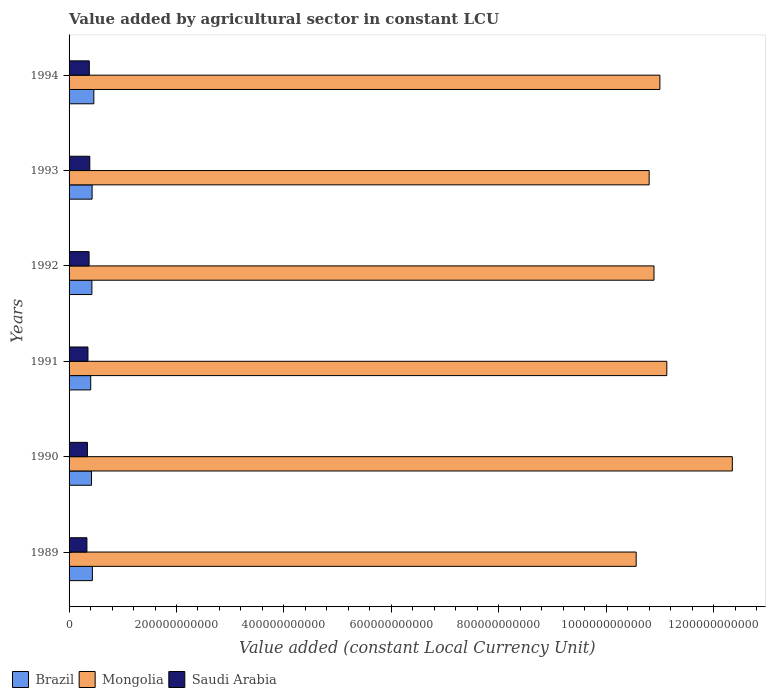How many different coloured bars are there?
Your answer should be compact. 3. Are the number of bars on each tick of the Y-axis equal?
Give a very brief answer. Yes. What is the label of the 3rd group of bars from the top?
Your answer should be very brief. 1992. In how many cases, is the number of bars for a given year not equal to the number of legend labels?
Provide a short and direct response. 0. What is the value added by agricultural sector in Brazil in 1989?
Make the answer very short. 4.34e+1. Across all years, what is the maximum value added by agricultural sector in Mongolia?
Make the answer very short. 1.23e+12. Across all years, what is the minimum value added by agricultural sector in Brazil?
Provide a succinct answer. 4.03e+1. In which year was the value added by agricultural sector in Mongolia maximum?
Make the answer very short. 1990. In which year was the value added by agricultural sector in Mongolia minimum?
Your answer should be compact. 1989. What is the total value added by agricultural sector in Brazil in the graph?
Provide a succinct answer. 2.57e+11. What is the difference between the value added by agricultural sector in Mongolia in 1993 and that in 1994?
Provide a short and direct response. -2.00e+1. What is the difference between the value added by agricultural sector in Mongolia in 1990 and the value added by agricultural sector in Brazil in 1989?
Keep it short and to the point. 1.19e+12. What is the average value added by agricultural sector in Brazil per year?
Offer a terse response. 4.28e+1. In the year 1992, what is the difference between the value added by agricultural sector in Mongolia and value added by agricultural sector in Saudi Arabia?
Give a very brief answer. 1.05e+12. In how many years, is the value added by agricultural sector in Saudi Arabia greater than 1200000000000 LCU?
Your answer should be very brief. 0. What is the ratio of the value added by agricultural sector in Mongolia in 1991 to that in 1992?
Offer a very short reply. 1.02. Is the difference between the value added by agricultural sector in Mongolia in 1992 and 1993 greater than the difference between the value added by agricultural sector in Saudi Arabia in 1992 and 1993?
Your answer should be compact. Yes. What is the difference between the highest and the second highest value added by agricultural sector in Saudi Arabia?
Offer a very short reply. 8.85e+08. What is the difference between the highest and the lowest value added by agricultural sector in Brazil?
Your answer should be compact. 5.80e+09. What does the 1st bar from the top in 1989 represents?
Provide a short and direct response. Saudi Arabia. Is it the case that in every year, the sum of the value added by agricultural sector in Mongolia and value added by agricultural sector in Saudi Arabia is greater than the value added by agricultural sector in Brazil?
Make the answer very short. Yes. How many bars are there?
Make the answer very short. 18. Are all the bars in the graph horizontal?
Offer a terse response. Yes. How many years are there in the graph?
Keep it short and to the point. 6. What is the difference between two consecutive major ticks on the X-axis?
Provide a short and direct response. 2.00e+11. Does the graph contain any zero values?
Your answer should be compact. No. Does the graph contain grids?
Provide a short and direct response. No. What is the title of the graph?
Provide a short and direct response. Value added by agricultural sector in constant LCU. What is the label or title of the X-axis?
Provide a succinct answer. Value added (constant Local Currency Unit). What is the label or title of the Y-axis?
Your response must be concise. Years. What is the Value added (constant Local Currency Unit) in Brazil in 1989?
Offer a very short reply. 4.34e+1. What is the Value added (constant Local Currency Unit) in Mongolia in 1989?
Keep it short and to the point. 1.06e+12. What is the Value added (constant Local Currency Unit) in Saudi Arabia in 1989?
Make the answer very short. 3.32e+1. What is the Value added (constant Local Currency Unit) in Brazil in 1990?
Provide a succinct answer. 4.18e+1. What is the Value added (constant Local Currency Unit) in Mongolia in 1990?
Provide a succinct answer. 1.23e+12. What is the Value added (constant Local Currency Unit) of Saudi Arabia in 1990?
Provide a short and direct response. 3.42e+1. What is the Value added (constant Local Currency Unit) of Brazil in 1991?
Offer a very short reply. 4.03e+1. What is the Value added (constant Local Currency Unit) in Mongolia in 1991?
Your answer should be very brief. 1.11e+12. What is the Value added (constant Local Currency Unit) of Saudi Arabia in 1991?
Your answer should be compact. 3.51e+1. What is the Value added (constant Local Currency Unit) of Brazil in 1992?
Provide a short and direct response. 4.25e+1. What is the Value added (constant Local Currency Unit) of Mongolia in 1992?
Provide a short and direct response. 1.09e+12. What is the Value added (constant Local Currency Unit) in Saudi Arabia in 1992?
Provide a short and direct response. 3.73e+1. What is the Value added (constant Local Currency Unit) of Brazil in 1993?
Your answer should be very brief. 4.29e+1. What is the Value added (constant Local Currency Unit) of Mongolia in 1993?
Your answer should be compact. 1.08e+12. What is the Value added (constant Local Currency Unit) in Saudi Arabia in 1993?
Your answer should be compact. 3.86e+1. What is the Value added (constant Local Currency Unit) in Brazil in 1994?
Ensure brevity in your answer.  4.61e+1. What is the Value added (constant Local Currency Unit) of Mongolia in 1994?
Make the answer very short. 1.10e+12. What is the Value added (constant Local Currency Unit) of Saudi Arabia in 1994?
Keep it short and to the point. 3.77e+1. Across all years, what is the maximum Value added (constant Local Currency Unit) of Brazil?
Keep it short and to the point. 4.61e+1. Across all years, what is the maximum Value added (constant Local Currency Unit) in Mongolia?
Your answer should be very brief. 1.23e+12. Across all years, what is the maximum Value added (constant Local Currency Unit) in Saudi Arabia?
Your response must be concise. 3.86e+1. Across all years, what is the minimum Value added (constant Local Currency Unit) of Brazil?
Make the answer very short. 4.03e+1. Across all years, what is the minimum Value added (constant Local Currency Unit) of Mongolia?
Offer a very short reply. 1.06e+12. Across all years, what is the minimum Value added (constant Local Currency Unit) of Saudi Arabia?
Your answer should be compact. 3.32e+1. What is the total Value added (constant Local Currency Unit) in Brazil in the graph?
Keep it short and to the point. 2.57e+11. What is the total Value added (constant Local Currency Unit) in Mongolia in the graph?
Your response must be concise. 6.67e+12. What is the total Value added (constant Local Currency Unit) in Saudi Arabia in the graph?
Your response must be concise. 2.16e+11. What is the difference between the Value added (constant Local Currency Unit) in Brazil in 1989 and that in 1990?
Make the answer very short. 1.61e+09. What is the difference between the Value added (constant Local Currency Unit) of Mongolia in 1989 and that in 1990?
Offer a very short reply. -1.79e+11. What is the difference between the Value added (constant Local Currency Unit) of Saudi Arabia in 1989 and that in 1990?
Make the answer very short. -9.31e+08. What is the difference between the Value added (constant Local Currency Unit) in Brazil in 1989 and that in 1991?
Your response must be concise. 3.11e+09. What is the difference between the Value added (constant Local Currency Unit) of Mongolia in 1989 and that in 1991?
Offer a very short reply. -5.70e+1. What is the difference between the Value added (constant Local Currency Unit) of Saudi Arabia in 1989 and that in 1991?
Provide a succinct answer. -1.92e+09. What is the difference between the Value added (constant Local Currency Unit) of Brazil in 1989 and that in 1992?
Ensure brevity in your answer.  9.21e+08. What is the difference between the Value added (constant Local Currency Unit) of Mongolia in 1989 and that in 1992?
Keep it short and to the point. -3.32e+1. What is the difference between the Value added (constant Local Currency Unit) in Saudi Arabia in 1989 and that in 1992?
Provide a succinct answer. -4.03e+09. What is the difference between the Value added (constant Local Currency Unit) of Brazil in 1989 and that in 1993?
Give a very brief answer. 5.02e+08. What is the difference between the Value added (constant Local Currency Unit) of Mongolia in 1989 and that in 1993?
Make the answer very short. -2.41e+1. What is the difference between the Value added (constant Local Currency Unit) in Saudi Arabia in 1989 and that in 1993?
Your answer should be compact. -5.34e+09. What is the difference between the Value added (constant Local Currency Unit) of Brazil in 1989 and that in 1994?
Provide a succinct answer. -2.69e+09. What is the difference between the Value added (constant Local Currency Unit) of Mongolia in 1989 and that in 1994?
Your answer should be very brief. -4.42e+1. What is the difference between the Value added (constant Local Currency Unit) of Saudi Arabia in 1989 and that in 1994?
Make the answer very short. -4.45e+09. What is the difference between the Value added (constant Local Currency Unit) in Brazil in 1990 and that in 1991?
Your answer should be compact. 1.51e+09. What is the difference between the Value added (constant Local Currency Unit) in Mongolia in 1990 and that in 1991?
Keep it short and to the point. 1.22e+11. What is the difference between the Value added (constant Local Currency Unit) in Saudi Arabia in 1990 and that in 1991?
Keep it short and to the point. -9.86e+08. What is the difference between the Value added (constant Local Currency Unit) of Brazil in 1990 and that in 1992?
Your answer should be very brief. -6.85e+08. What is the difference between the Value added (constant Local Currency Unit) of Mongolia in 1990 and that in 1992?
Your answer should be compact. 1.46e+11. What is the difference between the Value added (constant Local Currency Unit) of Saudi Arabia in 1990 and that in 1992?
Your answer should be very brief. -3.10e+09. What is the difference between the Value added (constant Local Currency Unit) of Brazil in 1990 and that in 1993?
Ensure brevity in your answer.  -1.10e+09. What is the difference between the Value added (constant Local Currency Unit) of Mongolia in 1990 and that in 1993?
Give a very brief answer. 1.55e+11. What is the difference between the Value added (constant Local Currency Unit) in Saudi Arabia in 1990 and that in 1993?
Keep it short and to the point. -4.41e+09. What is the difference between the Value added (constant Local Currency Unit) of Brazil in 1990 and that in 1994?
Provide a short and direct response. -4.30e+09. What is the difference between the Value added (constant Local Currency Unit) in Mongolia in 1990 and that in 1994?
Your response must be concise. 1.35e+11. What is the difference between the Value added (constant Local Currency Unit) of Saudi Arabia in 1990 and that in 1994?
Provide a short and direct response. -3.52e+09. What is the difference between the Value added (constant Local Currency Unit) of Brazil in 1991 and that in 1992?
Make the answer very short. -2.19e+09. What is the difference between the Value added (constant Local Currency Unit) in Mongolia in 1991 and that in 1992?
Keep it short and to the point. 2.38e+1. What is the difference between the Value added (constant Local Currency Unit) in Saudi Arabia in 1991 and that in 1992?
Your response must be concise. -2.12e+09. What is the difference between the Value added (constant Local Currency Unit) of Brazil in 1991 and that in 1993?
Provide a succinct answer. -2.61e+09. What is the difference between the Value added (constant Local Currency Unit) in Mongolia in 1991 and that in 1993?
Your answer should be compact. 3.29e+1. What is the difference between the Value added (constant Local Currency Unit) of Saudi Arabia in 1991 and that in 1993?
Provide a short and direct response. -3.42e+09. What is the difference between the Value added (constant Local Currency Unit) of Brazil in 1991 and that in 1994?
Ensure brevity in your answer.  -5.80e+09. What is the difference between the Value added (constant Local Currency Unit) in Mongolia in 1991 and that in 1994?
Your answer should be very brief. 1.29e+1. What is the difference between the Value added (constant Local Currency Unit) in Saudi Arabia in 1991 and that in 1994?
Ensure brevity in your answer.  -2.54e+09. What is the difference between the Value added (constant Local Currency Unit) in Brazil in 1992 and that in 1993?
Provide a succinct answer. -4.19e+08. What is the difference between the Value added (constant Local Currency Unit) of Mongolia in 1992 and that in 1993?
Your answer should be compact. 9.04e+09. What is the difference between the Value added (constant Local Currency Unit) of Saudi Arabia in 1992 and that in 1993?
Give a very brief answer. -1.31e+09. What is the difference between the Value added (constant Local Currency Unit) of Brazil in 1992 and that in 1994?
Keep it short and to the point. -3.61e+09. What is the difference between the Value added (constant Local Currency Unit) in Mongolia in 1992 and that in 1994?
Offer a terse response. -1.10e+1. What is the difference between the Value added (constant Local Currency Unit) of Saudi Arabia in 1992 and that in 1994?
Provide a succinct answer. -4.23e+08. What is the difference between the Value added (constant Local Currency Unit) in Brazil in 1993 and that in 1994?
Make the answer very short. -3.19e+09. What is the difference between the Value added (constant Local Currency Unit) of Mongolia in 1993 and that in 1994?
Make the answer very short. -2.00e+1. What is the difference between the Value added (constant Local Currency Unit) in Saudi Arabia in 1993 and that in 1994?
Provide a short and direct response. 8.85e+08. What is the difference between the Value added (constant Local Currency Unit) of Brazil in 1989 and the Value added (constant Local Currency Unit) of Mongolia in 1990?
Offer a terse response. -1.19e+12. What is the difference between the Value added (constant Local Currency Unit) in Brazil in 1989 and the Value added (constant Local Currency Unit) in Saudi Arabia in 1990?
Ensure brevity in your answer.  9.24e+09. What is the difference between the Value added (constant Local Currency Unit) of Mongolia in 1989 and the Value added (constant Local Currency Unit) of Saudi Arabia in 1990?
Provide a succinct answer. 1.02e+12. What is the difference between the Value added (constant Local Currency Unit) of Brazil in 1989 and the Value added (constant Local Currency Unit) of Mongolia in 1991?
Your response must be concise. -1.07e+12. What is the difference between the Value added (constant Local Currency Unit) of Brazil in 1989 and the Value added (constant Local Currency Unit) of Saudi Arabia in 1991?
Make the answer very short. 8.25e+09. What is the difference between the Value added (constant Local Currency Unit) of Mongolia in 1989 and the Value added (constant Local Currency Unit) of Saudi Arabia in 1991?
Offer a terse response. 1.02e+12. What is the difference between the Value added (constant Local Currency Unit) of Brazil in 1989 and the Value added (constant Local Currency Unit) of Mongolia in 1992?
Provide a succinct answer. -1.05e+12. What is the difference between the Value added (constant Local Currency Unit) in Brazil in 1989 and the Value added (constant Local Currency Unit) in Saudi Arabia in 1992?
Give a very brief answer. 6.14e+09. What is the difference between the Value added (constant Local Currency Unit) of Mongolia in 1989 and the Value added (constant Local Currency Unit) of Saudi Arabia in 1992?
Offer a very short reply. 1.02e+12. What is the difference between the Value added (constant Local Currency Unit) of Brazil in 1989 and the Value added (constant Local Currency Unit) of Mongolia in 1993?
Ensure brevity in your answer.  -1.04e+12. What is the difference between the Value added (constant Local Currency Unit) in Brazil in 1989 and the Value added (constant Local Currency Unit) in Saudi Arabia in 1993?
Your answer should be very brief. 4.83e+09. What is the difference between the Value added (constant Local Currency Unit) of Mongolia in 1989 and the Value added (constant Local Currency Unit) of Saudi Arabia in 1993?
Keep it short and to the point. 1.02e+12. What is the difference between the Value added (constant Local Currency Unit) in Brazil in 1989 and the Value added (constant Local Currency Unit) in Mongolia in 1994?
Provide a short and direct response. -1.06e+12. What is the difference between the Value added (constant Local Currency Unit) of Brazil in 1989 and the Value added (constant Local Currency Unit) of Saudi Arabia in 1994?
Offer a very short reply. 5.72e+09. What is the difference between the Value added (constant Local Currency Unit) of Mongolia in 1989 and the Value added (constant Local Currency Unit) of Saudi Arabia in 1994?
Keep it short and to the point. 1.02e+12. What is the difference between the Value added (constant Local Currency Unit) of Brazil in 1990 and the Value added (constant Local Currency Unit) of Mongolia in 1991?
Offer a terse response. -1.07e+12. What is the difference between the Value added (constant Local Currency Unit) in Brazil in 1990 and the Value added (constant Local Currency Unit) in Saudi Arabia in 1991?
Offer a terse response. 6.65e+09. What is the difference between the Value added (constant Local Currency Unit) in Mongolia in 1990 and the Value added (constant Local Currency Unit) in Saudi Arabia in 1991?
Provide a succinct answer. 1.20e+12. What is the difference between the Value added (constant Local Currency Unit) of Brazil in 1990 and the Value added (constant Local Currency Unit) of Mongolia in 1992?
Offer a very short reply. -1.05e+12. What is the difference between the Value added (constant Local Currency Unit) in Brazil in 1990 and the Value added (constant Local Currency Unit) in Saudi Arabia in 1992?
Your answer should be very brief. 4.53e+09. What is the difference between the Value added (constant Local Currency Unit) of Mongolia in 1990 and the Value added (constant Local Currency Unit) of Saudi Arabia in 1992?
Your answer should be compact. 1.20e+12. What is the difference between the Value added (constant Local Currency Unit) in Brazil in 1990 and the Value added (constant Local Currency Unit) in Mongolia in 1993?
Keep it short and to the point. -1.04e+12. What is the difference between the Value added (constant Local Currency Unit) in Brazil in 1990 and the Value added (constant Local Currency Unit) in Saudi Arabia in 1993?
Ensure brevity in your answer.  3.22e+09. What is the difference between the Value added (constant Local Currency Unit) in Mongolia in 1990 and the Value added (constant Local Currency Unit) in Saudi Arabia in 1993?
Make the answer very short. 1.20e+12. What is the difference between the Value added (constant Local Currency Unit) of Brazil in 1990 and the Value added (constant Local Currency Unit) of Mongolia in 1994?
Ensure brevity in your answer.  -1.06e+12. What is the difference between the Value added (constant Local Currency Unit) in Brazil in 1990 and the Value added (constant Local Currency Unit) in Saudi Arabia in 1994?
Ensure brevity in your answer.  4.11e+09. What is the difference between the Value added (constant Local Currency Unit) of Mongolia in 1990 and the Value added (constant Local Currency Unit) of Saudi Arabia in 1994?
Ensure brevity in your answer.  1.20e+12. What is the difference between the Value added (constant Local Currency Unit) of Brazil in 1991 and the Value added (constant Local Currency Unit) of Mongolia in 1992?
Keep it short and to the point. -1.05e+12. What is the difference between the Value added (constant Local Currency Unit) of Brazil in 1991 and the Value added (constant Local Currency Unit) of Saudi Arabia in 1992?
Offer a very short reply. 3.03e+09. What is the difference between the Value added (constant Local Currency Unit) in Mongolia in 1991 and the Value added (constant Local Currency Unit) in Saudi Arabia in 1992?
Make the answer very short. 1.08e+12. What is the difference between the Value added (constant Local Currency Unit) of Brazil in 1991 and the Value added (constant Local Currency Unit) of Mongolia in 1993?
Offer a very short reply. -1.04e+12. What is the difference between the Value added (constant Local Currency Unit) of Brazil in 1991 and the Value added (constant Local Currency Unit) of Saudi Arabia in 1993?
Offer a terse response. 1.72e+09. What is the difference between the Value added (constant Local Currency Unit) in Mongolia in 1991 and the Value added (constant Local Currency Unit) in Saudi Arabia in 1993?
Make the answer very short. 1.07e+12. What is the difference between the Value added (constant Local Currency Unit) in Brazil in 1991 and the Value added (constant Local Currency Unit) in Mongolia in 1994?
Offer a terse response. -1.06e+12. What is the difference between the Value added (constant Local Currency Unit) in Brazil in 1991 and the Value added (constant Local Currency Unit) in Saudi Arabia in 1994?
Ensure brevity in your answer.  2.60e+09. What is the difference between the Value added (constant Local Currency Unit) of Mongolia in 1991 and the Value added (constant Local Currency Unit) of Saudi Arabia in 1994?
Your response must be concise. 1.08e+12. What is the difference between the Value added (constant Local Currency Unit) in Brazil in 1992 and the Value added (constant Local Currency Unit) in Mongolia in 1993?
Provide a succinct answer. -1.04e+12. What is the difference between the Value added (constant Local Currency Unit) of Brazil in 1992 and the Value added (constant Local Currency Unit) of Saudi Arabia in 1993?
Ensure brevity in your answer.  3.91e+09. What is the difference between the Value added (constant Local Currency Unit) of Mongolia in 1992 and the Value added (constant Local Currency Unit) of Saudi Arabia in 1993?
Your response must be concise. 1.05e+12. What is the difference between the Value added (constant Local Currency Unit) in Brazil in 1992 and the Value added (constant Local Currency Unit) in Mongolia in 1994?
Offer a terse response. -1.06e+12. What is the difference between the Value added (constant Local Currency Unit) of Brazil in 1992 and the Value added (constant Local Currency Unit) of Saudi Arabia in 1994?
Your answer should be very brief. 4.79e+09. What is the difference between the Value added (constant Local Currency Unit) of Mongolia in 1992 and the Value added (constant Local Currency Unit) of Saudi Arabia in 1994?
Your response must be concise. 1.05e+12. What is the difference between the Value added (constant Local Currency Unit) of Brazil in 1993 and the Value added (constant Local Currency Unit) of Mongolia in 1994?
Give a very brief answer. -1.06e+12. What is the difference between the Value added (constant Local Currency Unit) of Brazil in 1993 and the Value added (constant Local Currency Unit) of Saudi Arabia in 1994?
Offer a terse response. 5.21e+09. What is the difference between the Value added (constant Local Currency Unit) in Mongolia in 1993 and the Value added (constant Local Currency Unit) in Saudi Arabia in 1994?
Offer a terse response. 1.04e+12. What is the average Value added (constant Local Currency Unit) of Brazil per year?
Keep it short and to the point. 4.28e+1. What is the average Value added (constant Local Currency Unit) in Mongolia per year?
Provide a succinct answer. 1.11e+12. What is the average Value added (constant Local Currency Unit) in Saudi Arabia per year?
Keep it short and to the point. 3.60e+1. In the year 1989, what is the difference between the Value added (constant Local Currency Unit) in Brazil and Value added (constant Local Currency Unit) in Mongolia?
Your response must be concise. -1.01e+12. In the year 1989, what is the difference between the Value added (constant Local Currency Unit) in Brazil and Value added (constant Local Currency Unit) in Saudi Arabia?
Your response must be concise. 1.02e+1. In the year 1989, what is the difference between the Value added (constant Local Currency Unit) of Mongolia and Value added (constant Local Currency Unit) of Saudi Arabia?
Ensure brevity in your answer.  1.02e+12. In the year 1990, what is the difference between the Value added (constant Local Currency Unit) of Brazil and Value added (constant Local Currency Unit) of Mongolia?
Your answer should be compact. -1.19e+12. In the year 1990, what is the difference between the Value added (constant Local Currency Unit) of Brazil and Value added (constant Local Currency Unit) of Saudi Arabia?
Provide a succinct answer. 7.63e+09. In the year 1990, what is the difference between the Value added (constant Local Currency Unit) of Mongolia and Value added (constant Local Currency Unit) of Saudi Arabia?
Offer a terse response. 1.20e+12. In the year 1991, what is the difference between the Value added (constant Local Currency Unit) in Brazil and Value added (constant Local Currency Unit) in Mongolia?
Offer a very short reply. -1.07e+12. In the year 1991, what is the difference between the Value added (constant Local Currency Unit) in Brazil and Value added (constant Local Currency Unit) in Saudi Arabia?
Make the answer very short. 5.14e+09. In the year 1991, what is the difference between the Value added (constant Local Currency Unit) in Mongolia and Value added (constant Local Currency Unit) in Saudi Arabia?
Ensure brevity in your answer.  1.08e+12. In the year 1992, what is the difference between the Value added (constant Local Currency Unit) in Brazil and Value added (constant Local Currency Unit) in Mongolia?
Provide a succinct answer. -1.05e+12. In the year 1992, what is the difference between the Value added (constant Local Currency Unit) of Brazil and Value added (constant Local Currency Unit) of Saudi Arabia?
Keep it short and to the point. 5.22e+09. In the year 1992, what is the difference between the Value added (constant Local Currency Unit) of Mongolia and Value added (constant Local Currency Unit) of Saudi Arabia?
Offer a terse response. 1.05e+12. In the year 1993, what is the difference between the Value added (constant Local Currency Unit) in Brazil and Value added (constant Local Currency Unit) in Mongolia?
Provide a succinct answer. -1.04e+12. In the year 1993, what is the difference between the Value added (constant Local Currency Unit) of Brazil and Value added (constant Local Currency Unit) of Saudi Arabia?
Keep it short and to the point. 4.33e+09. In the year 1993, what is the difference between the Value added (constant Local Currency Unit) of Mongolia and Value added (constant Local Currency Unit) of Saudi Arabia?
Provide a succinct answer. 1.04e+12. In the year 1994, what is the difference between the Value added (constant Local Currency Unit) in Brazil and Value added (constant Local Currency Unit) in Mongolia?
Offer a very short reply. -1.05e+12. In the year 1994, what is the difference between the Value added (constant Local Currency Unit) in Brazil and Value added (constant Local Currency Unit) in Saudi Arabia?
Your answer should be very brief. 8.41e+09. In the year 1994, what is the difference between the Value added (constant Local Currency Unit) of Mongolia and Value added (constant Local Currency Unit) of Saudi Arabia?
Your answer should be compact. 1.06e+12. What is the ratio of the Value added (constant Local Currency Unit) of Brazil in 1989 to that in 1990?
Make the answer very short. 1.04. What is the ratio of the Value added (constant Local Currency Unit) in Mongolia in 1989 to that in 1990?
Provide a short and direct response. 0.85. What is the ratio of the Value added (constant Local Currency Unit) of Saudi Arabia in 1989 to that in 1990?
Make the answer very short. 0.97. What is the ratio of the Value added (constant Local Currency Unit) of Brazil in 1989 to that in 1991?
Keep it short and to the point. 1.08. What is the ratio of the Value added (constant Local Currency Unit) in Mongolia in 1989 to that in 1991?
Your answer should be compact. 0.95. What is the ratio of the Value added (constant Local Currency Unit) in Saudi Arabia in 1989 to that in 1991?
Your response must be concise. 0.95. What is the ratio of the Value added (constant Local Currency Unit) of Brazil in 1989 to that in 1992?
Your answer should be compact. 1.02. What is the ratio of the Value added (constant Local Currency Unit) of Mongolia in 1989 to that in 1992?
Provide a short and direct response. 0.97. What is the ratio of the Value added (constant Local Currency Unit) of Saudi Arabia in 1989 to that in 1992?
Provide a short and direct response. 0.89. What is the ratio of the Value added (constant Local Currency Unit) in Brazil in 1989 to that in 1993?
Provide a short and direct response. 1.01. What is the ratio of the Value added (constant Local Currency Unit) of Mongolia in 1989 to that in 1993?
Your answer should be compact. 0.98. What is the ratio of the Value added (constant Local Currency Unit) of Saudi Arabia in 1989 to that in 1993?
Your response must be concise. 0.86. What is the ratio of the Value added (constant Local Currency Unit) of Brazil in 1989 to that in 1994?
Your answer should be very brief. 0.94. What is the ratio of the Value added (constant Local Currency Unit) in Mongolia in 1989 to that in 1994?
Your answer should be compact. 0.96. What is the ratio of the Value added (constant Local Currency Unit) of Saudi Arabia in 1989 to that in 1994?
Make the answer very short. 0.88. What is the ratio of the Value added (constant Local Currency Unit) in Brazil in 1990 to that in 1991?
Offer a very short reply. 1.04. What is the ratio of the Value added (constant Local Currency Unit) in Mongolia in 1990 to that in 1991?
Your response must be concise. 1.11. What is the ratio of the Value added (constant Local Currency Unit) of Brazil in 1990 to that in 1992?
Provide a short and direct response. 0.98. What is the ratio of the Value added (constant Local Currency Unit) in Mongolia in 1990 to that in 1992?
Your answer should be compact. 1.13. What is the ratio of the Value added (constant Local Currency Unit) in Saudi Arabia in 1990 to that in 1992?
Offer a very short reply. 0.92. What is the ratio of the Value added (constant Local Currency Unit) in Brazil in 1990 to that in 1993?
Provide a short and direct response. 0.97. What is the ratio of the Value added (constant Local Currency Unit) in Mongolia in 1990 to that in 1993?
Ensure brevity in your answer.  1.14. What is the ratio of the Value added (constant Local Currency Unit) of Saudi Arabia in 1990 to that in 1993?
Offer a terse response. 0.89. What is the ratio of the Value added (constant Local Currency Unit) in Brazil in 1990 to that in 1994?
Ensure brevity in your answer.  0.91. What is the ratio of the Value added (constant Local Currency Unit) of Mongolia in 1990 to that in 1994?
Provide a succinct answer. 1.12. What is the ratio of the Value added (constant Local Currency Unit) of Saudi Arabia in 1990 to that in 1994?
Your response must be concise. 0.91. What is the ratio of the Value added (constant Local Currency Unit) in Brazil in 1991 to that in 1992?
Make the answer very short. 0.95. What is the ratio of the Value added (constant Local Currency Unit) of Mongolia in 1991 to that in 1992?
Keep it short and to the point. 1.02. What is the ratio of the Value added (constant Local Currency Unit) of Saudi Arabia in 1991 to that in 1992?
Ensure brevity in your answer.  0.94. What is the ratio of the Value added (constant Local Currency Unit) of Brazil in 1991 to that in 1993?
Offer a terse response. 0.94. What is the ratio of the Value added (constant Local Currency Unit) of Mongolia in 1991 to that in 1993?
Make the answer very short. 1.03. What is the ratio of the Value added (constant Local Currency Unit) of Saudi Arabia in 1991 to that in 1993?
Your answer should be very brief. 0.91. What is the ratio of the Value added (constant Local Currency Unit) of Brazil in 1991 to that in 1994?
Give a very brief answer. 0.87. What is the ratio of the Value added (constant Local Currency Unit) in Mongolia in 1991 to that in 1994?
Give a very brief answer. 1.01. What is the ratio of the Value added (constant Local Currency Unit) in Saudi Arabia in 1991 to that in 1994?
Offer a very short reply. 0.93. What is the ratio of the Value added (constant Local Currency Unit) in Brazil in 1992 to that in 1993?
Provide a short and direct response. 0.99. What is the ratio of the Value added (constant Local Currency Unit) in Mongolia in 1992 to that in 1993?
Ensure brevity in your answer.  1.01. What is the ratio of the Value added (constant Local Currency Unit) of Saudi Arabia in 1992 to that in 1993?
Your response must be concise. 0.97. What is the ratio of the Value added (constant Local Currency Unit) of Brazil in 1992 to that in 1994?
Ensure brevity in your answer.  0.92. What is the ratio of the Value added (constant Local Currency Unit) of Mongolia in 1992 to that in 1994?
Your response must be concise. 0.99. What is the ratio of the Value added (constant Local Currency Unit) in Brazil in 1993 to that in 1994?
Your answer should be very brief. 0.93. What is the ratio of the Value added (constant Local Currency Unit) of Mongolia in 1993 to that in 1994?
Provide a succinct answer. 0.98. What is the ratio of the Value added (constant Local Currency Unit) in Saudi Arabia in 1993 to that in 1994?
Offer a terse response. 1.02. What is the difference between the highest and the second highest Value added (constant Local Currency Unit) of Brazil?
Offer a terse response. 2.69e+09. What is the difference between the highest and the second highest Value added (constant Local Currency Unit) in Mongolia?
Provide a succinct answer. 1.22e+11. What is the difference between the highest and the second highest Value added (constant Local Currency Unit) in Saudi Arabia?
Give a very brief answer. 8.85e+08. What is the difference between the highest and the lowest Value added (constant Local Currency Unit) of Brazil?
Give a very brief answer. 5.80e+09. What is the difference between the highest and the lowest Value added (constant Local Currency Unit) of Mongolia?
Your response must be concise. 1.79e+11. What is the difference between the highest and the lowest Value added (constant Local Currency Unit) in Saudi Arabia?
Provide a short and direct response. 5.34e+09. 